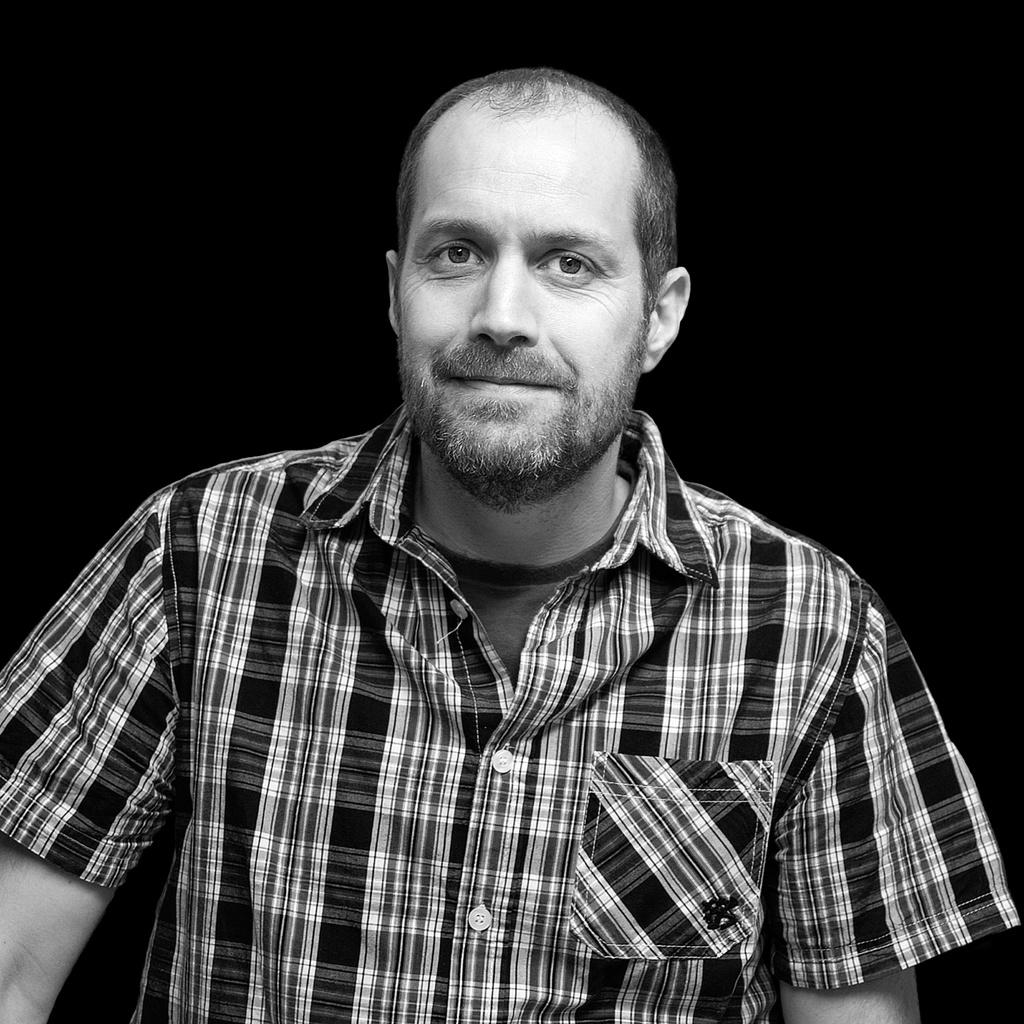What is the color scheme of the image? The image is black and white. Who is present in the image? There is a man in the image. What is the man wearing? The man is wearing a shirt. What is the man's facial expression in the image? The man is smiling. What is the man doing in the image? The man is giving a pose for the picture. What can be seen in the background of the image? The background of the image is dark. How many cattle can be seen in the image? There are no cattle present in the image. 